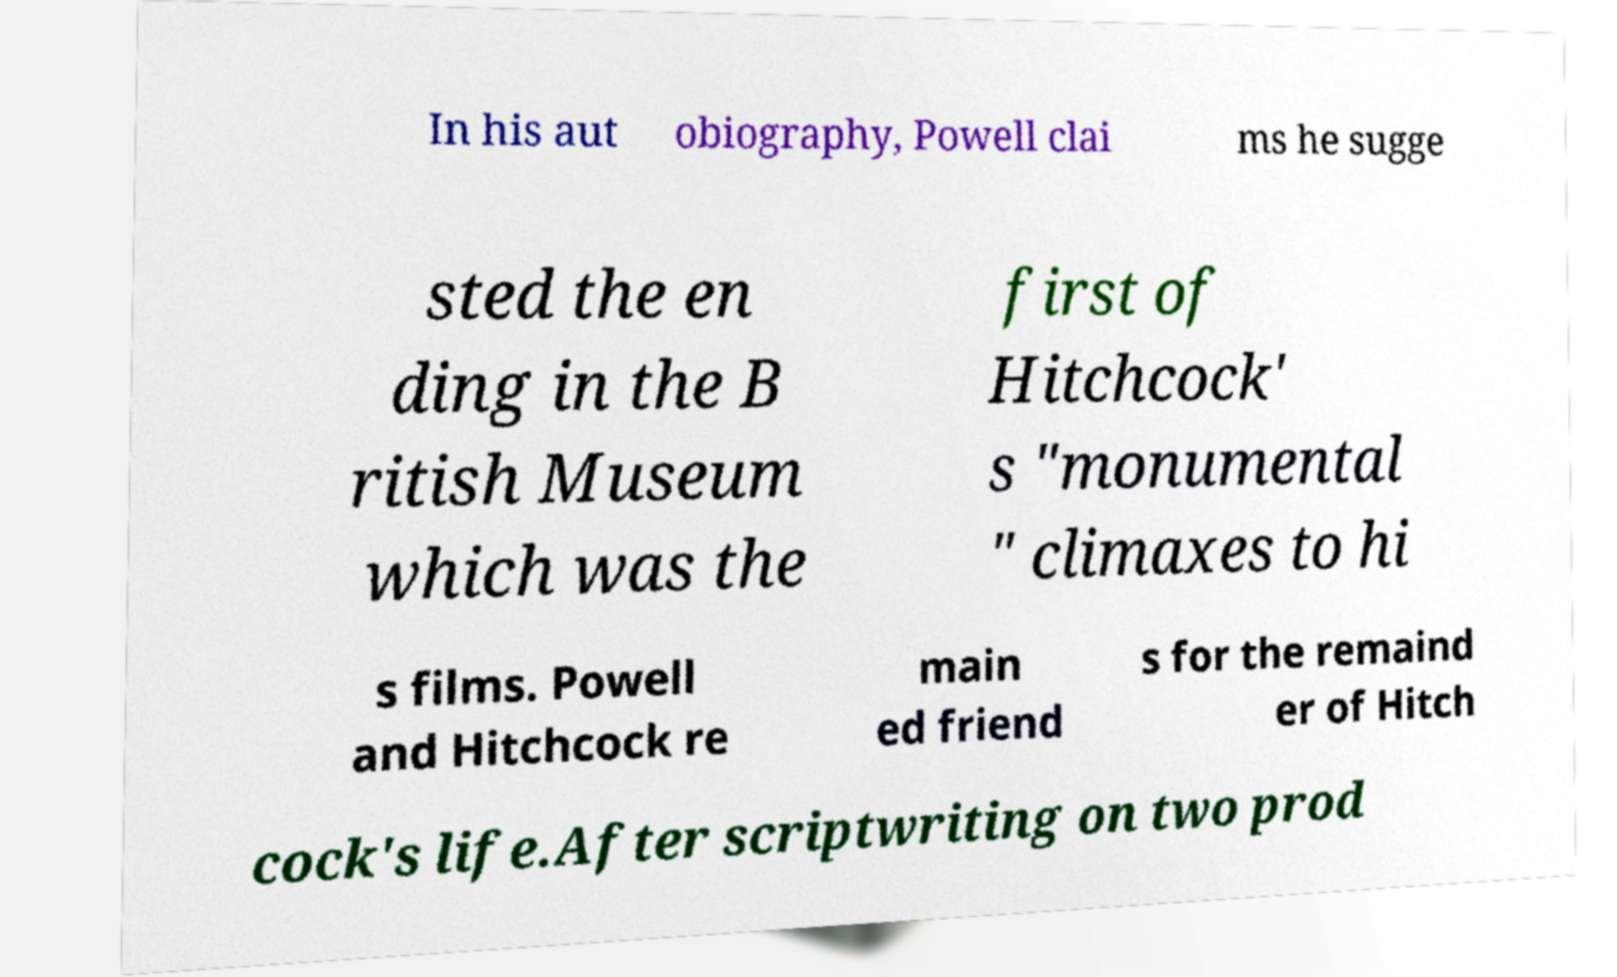What messages or text are displayed in this image? I need them in a readable, typed format. In his aut obiography, Powell clai ms he sugge sted the en ding in the B ritish Museum which was the first of Hitchcock' s "monumental " climaxes to hi s films. Powell and Hitchcock re main ed friend s for the remaind er of Hitch cock's life.After scriptwriting on two prod 